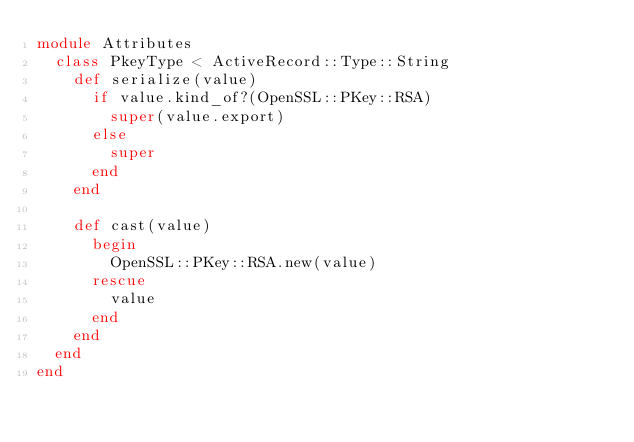Convert code to text. <code><loc_0><loc_0><loc_500><loc_500><_Ruby_>module Attributes
  class PkeyType < ActiveRecord::Type::String
    def serialize(value)
      if value.kind_of?(OpenSSL::PKey::RSA)
        super(value.export)
      else
        super
      end
    end

    def cast(value)
      begin
        OpenSSL::PKey::RSA.new(value)
      rescue
        value
      end
    end
  end
end
</code> 